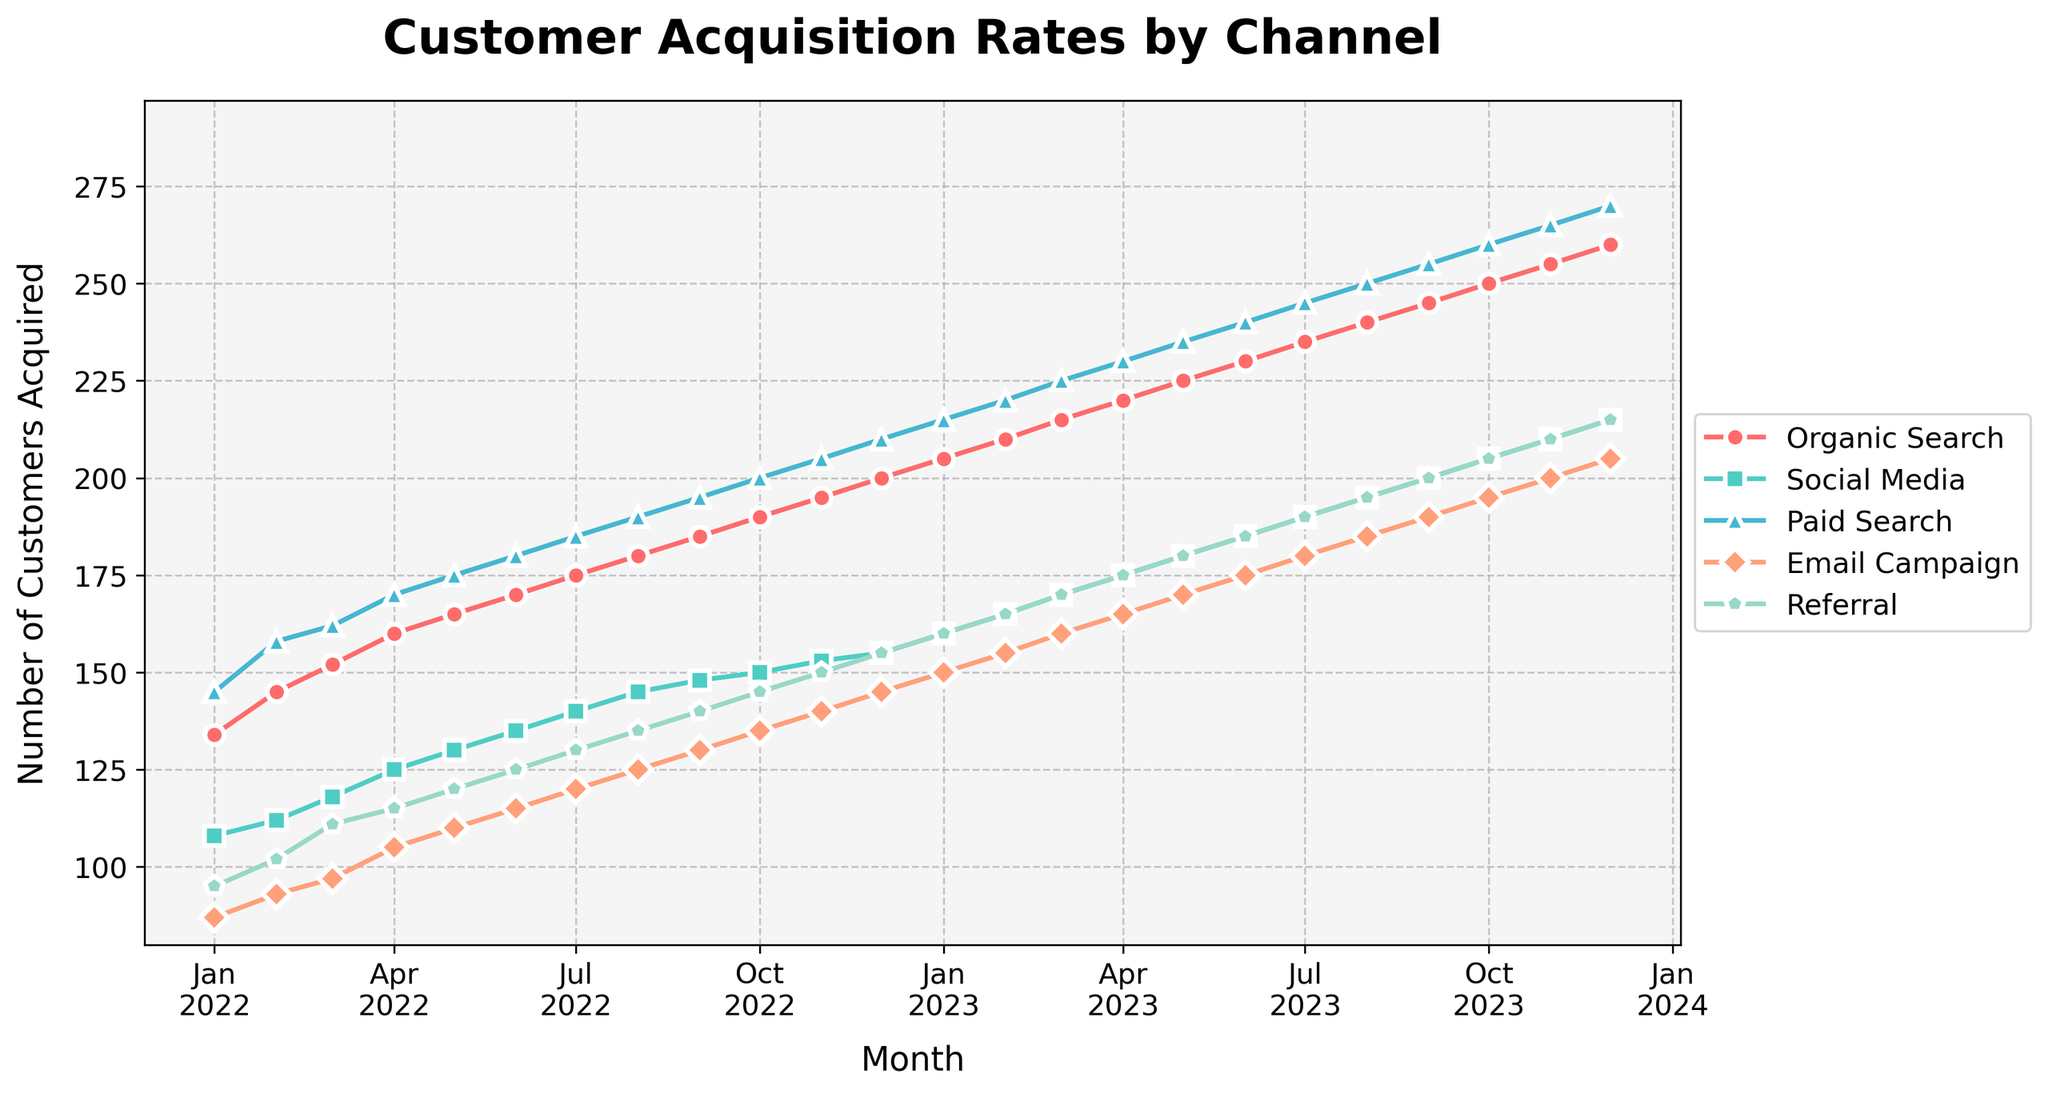What is the title of the figure? The title of a plot is typically located at the top of the figure in a larger and bolder font compared to the rest of the text. In this figure, the title displayed is at the top in a large bold font
Answer: Customer Acquisition Rates by Channel Over which time period is the data spread? To determine the time period, look at the x-axis of the plot, which typically shows the date range. In this figure, the x-axis indicates it starts from Jan 2022 and ends in Dec 2023
Answer: January 2022 to December 2023 Which channel had the highest acquisition rate in December 2023? Look for the data points in December 2023 on the x-axis and then identify the channel with the highest value on the y-axis. The highest point at the end of the plot corresponds to the 'Paid Search' channel
Answer: Paid Search What was the customer acquisition rate from Email Campaigns in July 2022? Locate July 2022 on the x-axis and follow it vertically up to the data point associated with 'Email Campaigns'. The marker shows the acquisition rate
Answer: 120 Compare the acquisition rates of Organic Search and Social Media in January 2023. Which one is higher? Find January 2023 on the x-axis, then compare the y-values of the 'Organic Search' and 'Social Media' data points. 'Organic Search' is higher than 'Social Media'
Answer: Organic Search What is the overall trend in customer acquisition rates for the Social Media channel over the year 2023? Observe the plot and focus on the data points for 'Social Media' throughout the year 2023. The acquisition rate steadily increases each month
Answer: Increasing Calculate the average customer acquisition rate for the Referral channel in the first quarter of 2023. The first quarter of 2023 includes January, February, and March. Note the values for 'Referral' in these months (160, 165, 170), sum them up and divide by 3. (160+165+170)/3 = 165
Answer: 165 How much did the customer acquisition rate from Paid Search increase from January 2022 to December 2023? Identify the values for 'Paid Search' in January 2022 (145) and December 2023 (270). The increase is found by calculating the difference: 270 - 145
Answer: 125 Are there any months where the acquisition rate for the Email Campaign channel decreased compared to the previous month? If so, which month(s)? Examine the Email Campaign data points month by month. The acquisition rate consistently increases or remains the same; no month shows a decrease
Answer: No Which two channels have the most similar customer acquisition rates in October 2022? For October 2022, check the y-values for all channels and compare them to find the closest ones. 'Social Media' (150) and 'Email Campaign' (135) are the closest in value
Answer: Social Media and Email Campaign 